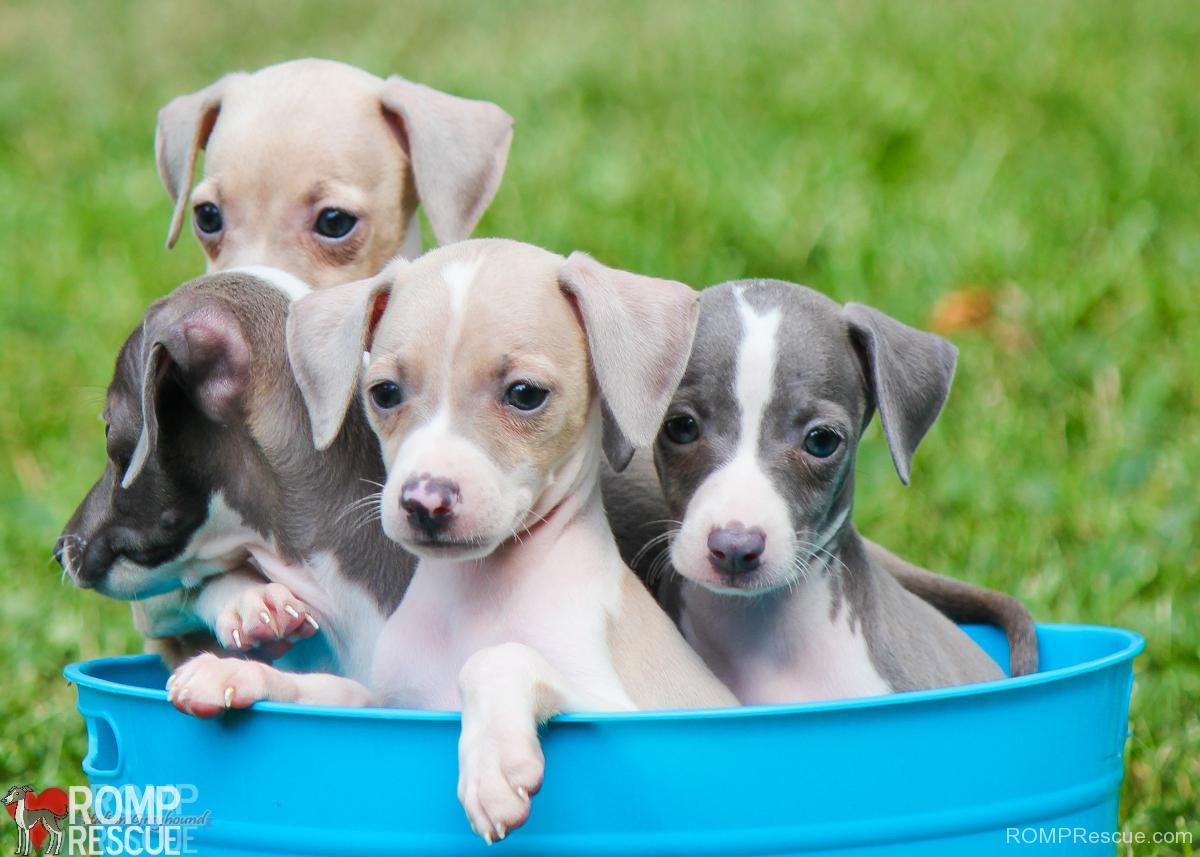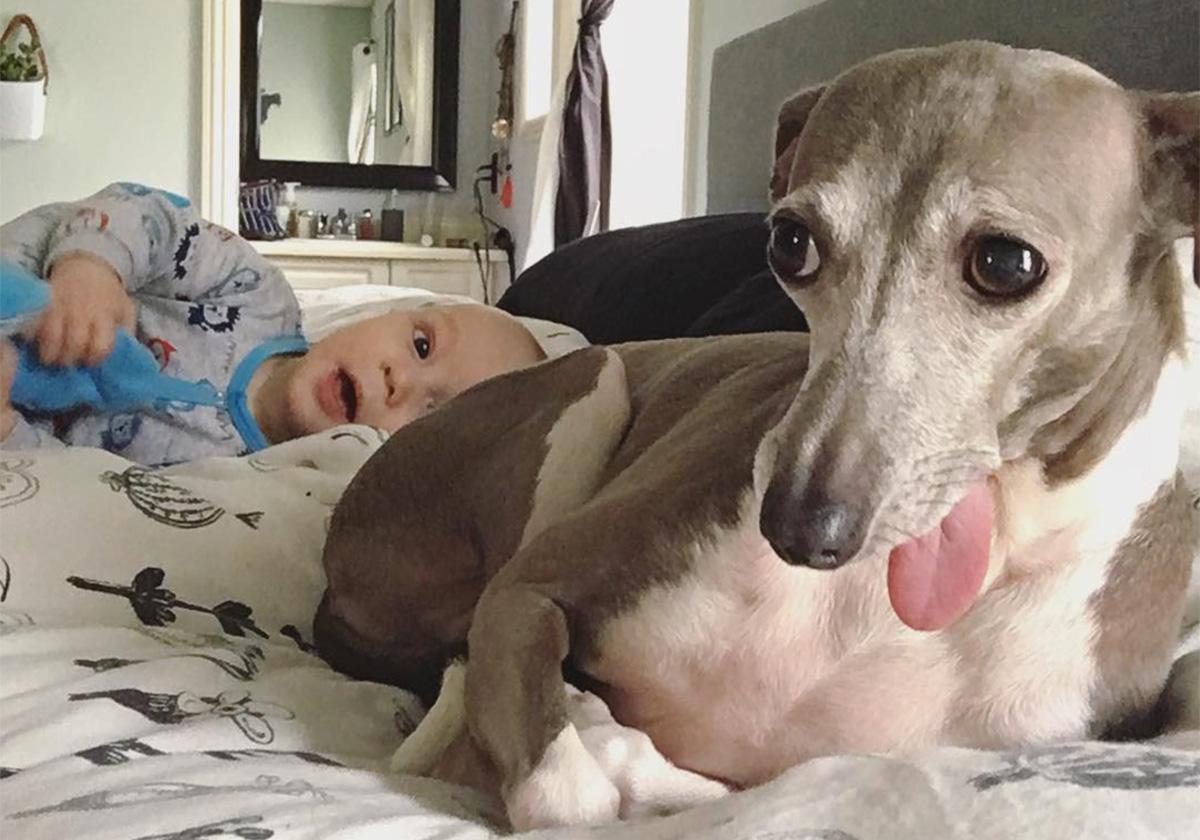The first image is the image on the left, the second image is the image on the right. Assess this claim about the two images: "A person is holding the dog in the image on the left.". Correct or not? Answer yes or no. No. The first image is the image on the left, the second image is the image on the right. Assess this claim about the two images: "There is at least five dogs.". Correct or not? Answer yes or no. Yes. 